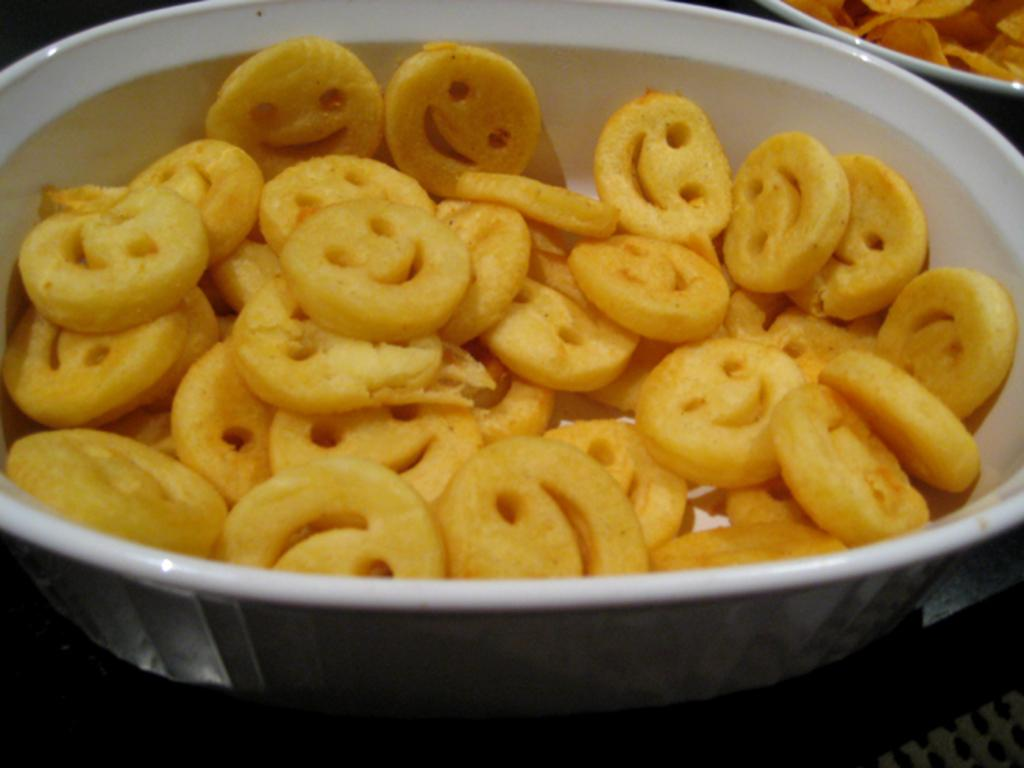What objects are present in the image? There are bowls in the image. What is inside the bowls? There are food items in the bowls. What type of animal can be seen playing in the park in the image? There is no animal or park present in the image; it only features bowls with food items. 